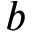<formula> <loc_0><loc_0><loc_500><loc_500>b</formula> 